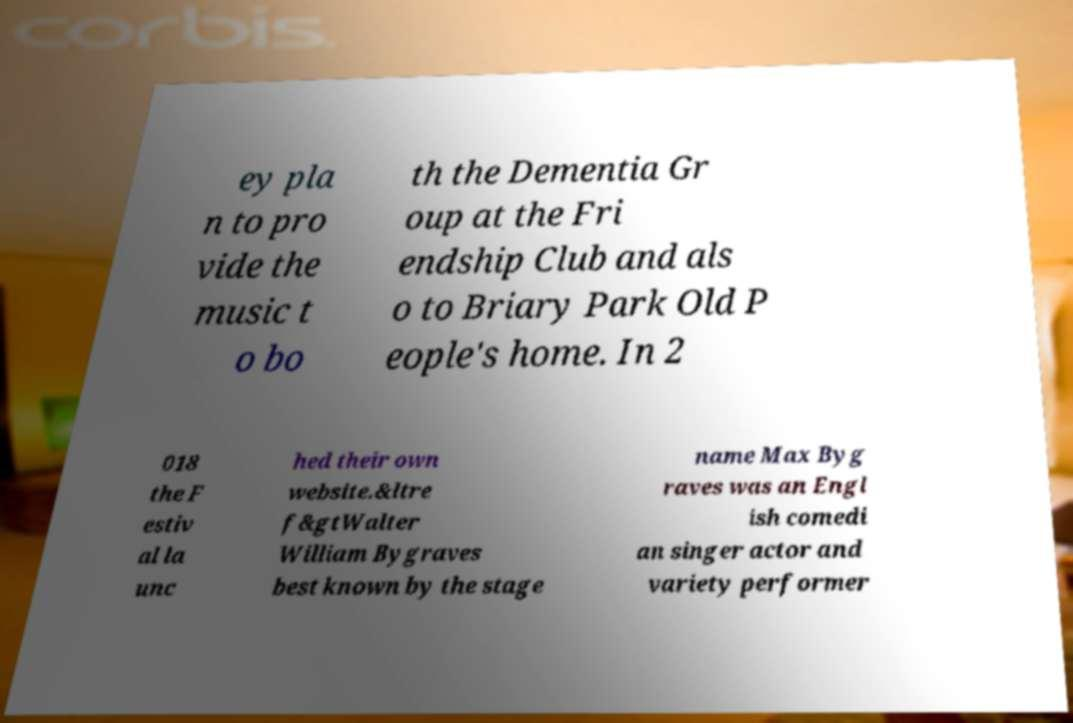Please identify and transcribe the text found in this image. ey pla n to pro vide the music t o bo th the Dementia Gr oup at the Fri endship Club and als o to Briary Park Old P eople's home. In 2 018 the F estiv al la unc hed their own website.&ltre f&gtWalter William Bygraves best known by the stage name Max Byg raves was an Engl ish comedi an singer actor and variety performer 